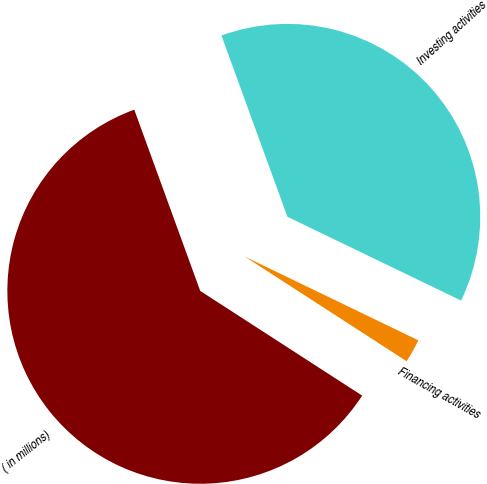<chart> <loc_0><loc_0><loc_500><loc_500><pie_chart><fcel>( in millions)<fcel>Investing activities<fcel>Financing activities<nl><fcel>60.31%<fcel>37.71%<fcel>1.98%<nl></chart> 